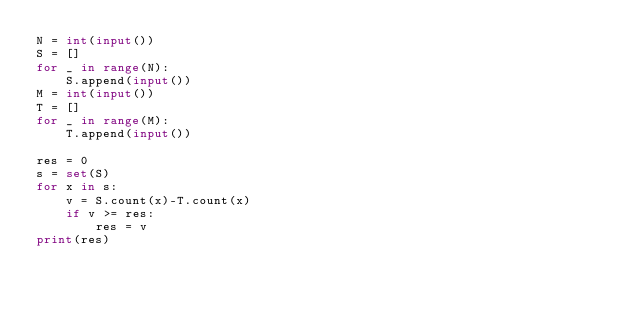<code> <loc_0><loc_0><loc_500><loc_500><_Python_>N = int(input())
S = []
for _ in range(N):
    S.append(input())
M = int(input())
T = []
for _ in range(M):
    T.append(input())

res = 0
s = set(S)
for x in s:
    v = S.count(x)-T.count(x)
    if v >= res:
        res = v
print(res) </code> 